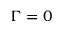<formula> <loc_0><loc_0><loc_500><loc_500>\Gamma = 0</formula> 